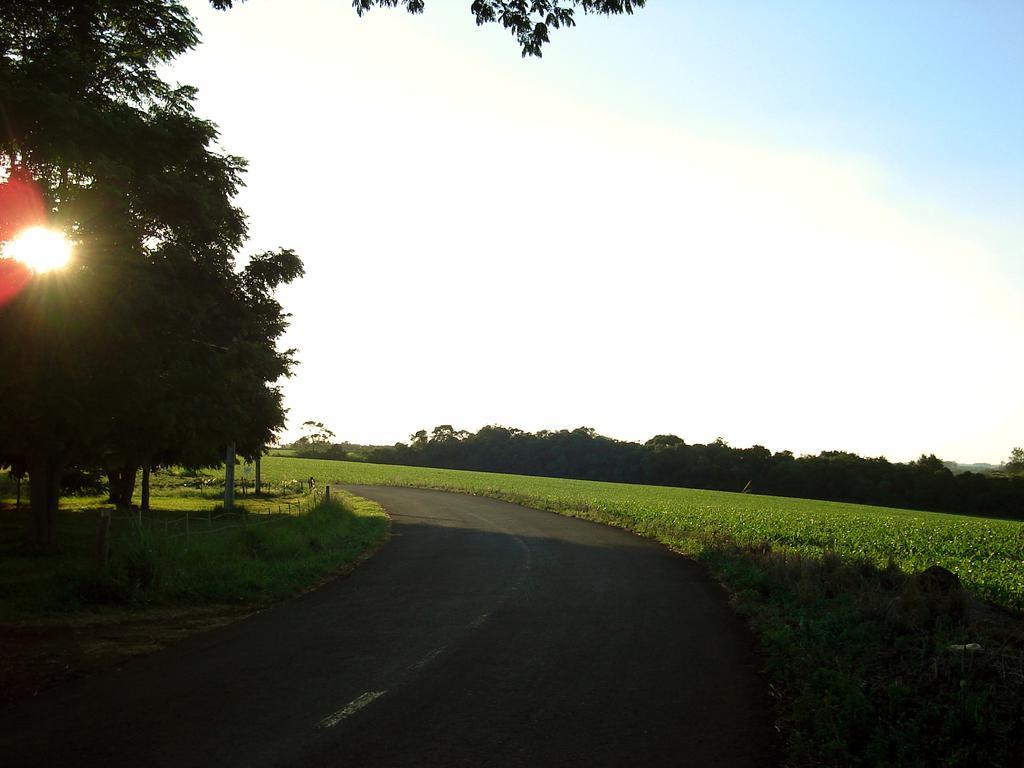Describe this image in one or two sentences. In this image, I can see the road, plants, grass, fence and trees. In the background, there is the sky. 